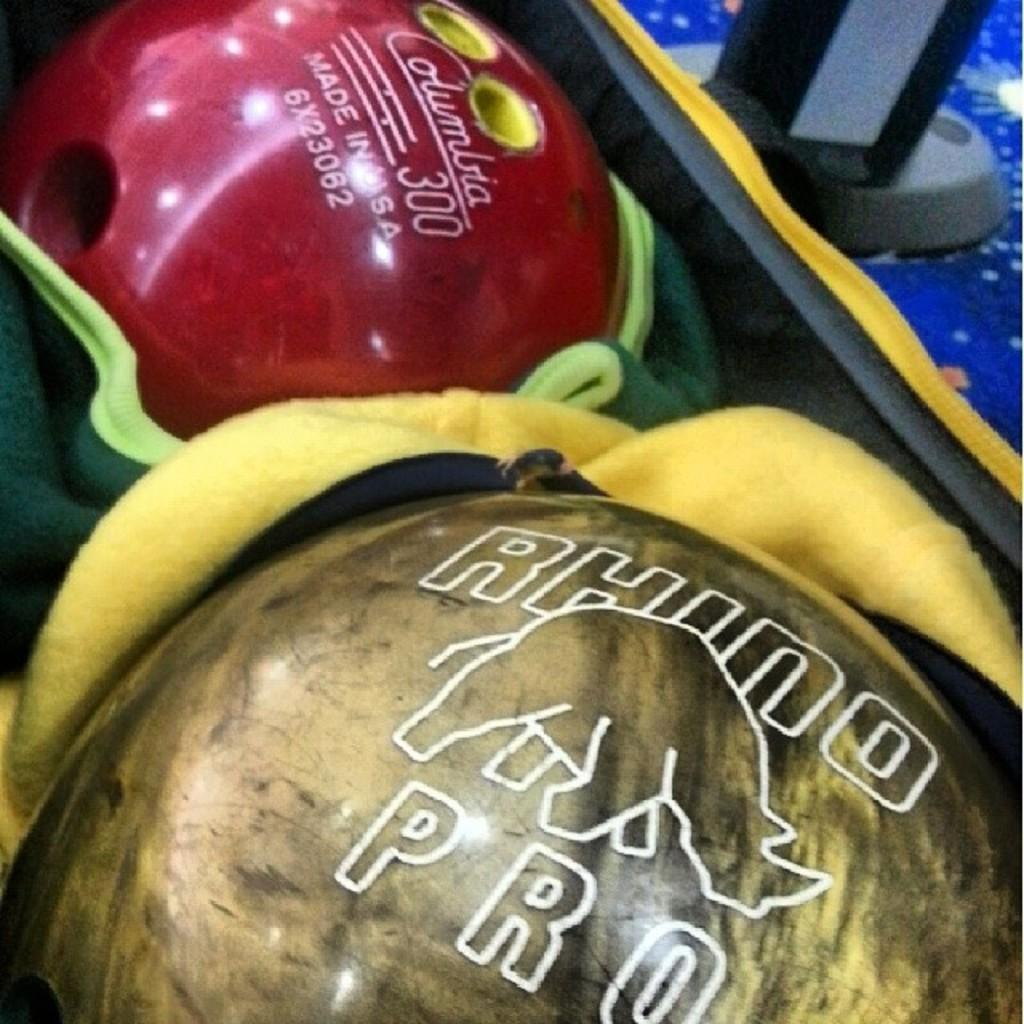What type of sports equipment can be seen in the image? There are bowling balls in the image. What else is present in the image besides the bowling balls? There are clothes and unspecified objects in the image. What type of table is used for the bowling balls in the image? There is no table present in the image; the bowling balls are not on a table. 